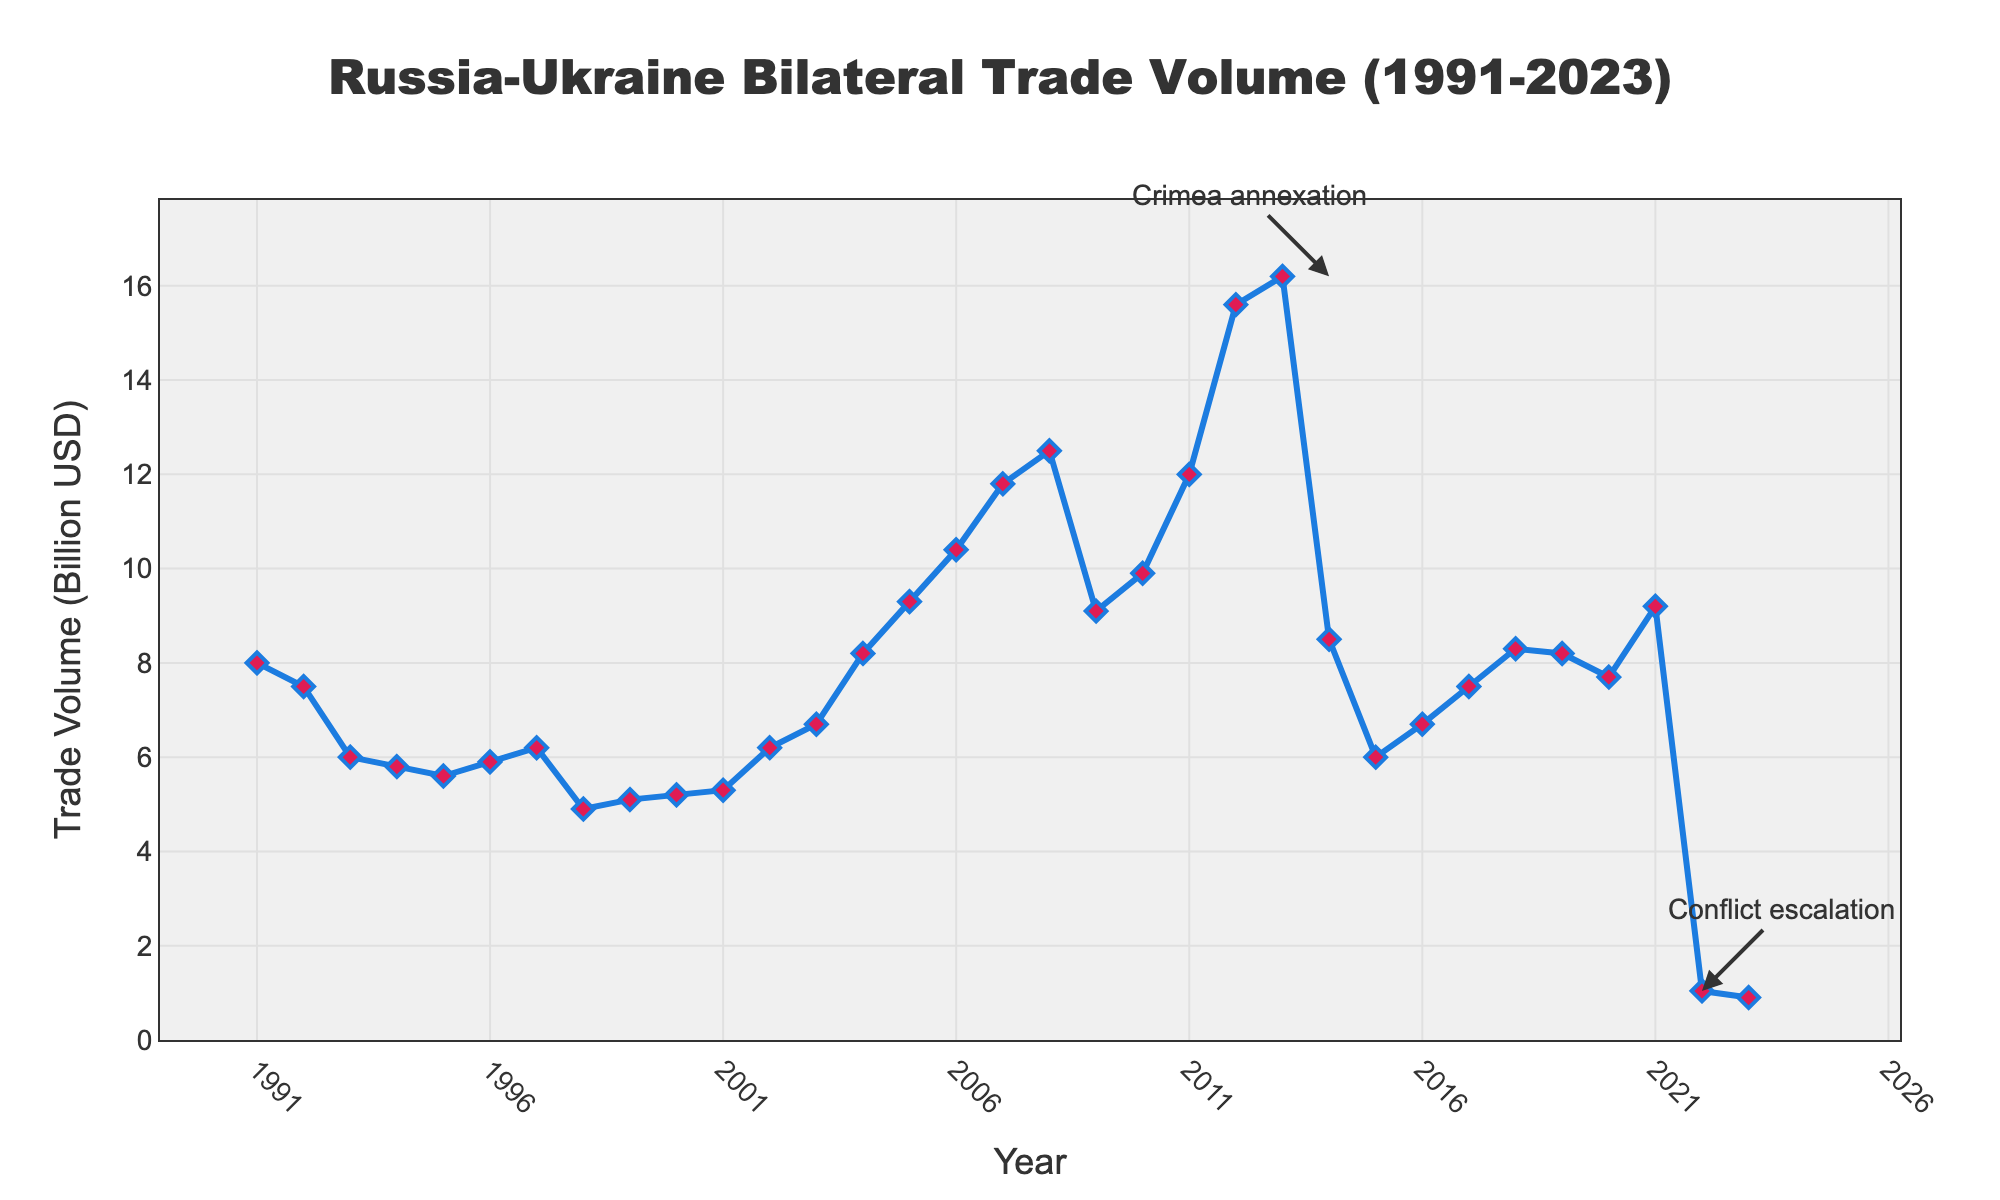What is the title of the figure? The title is typically found at the top center of the figure. It summarizes the main topic of the graph. For this figure, it's indicated by a larger font size and distinctive coloring.
Answer: Russia-Ukraine Bilateral Trade Volume (1991-2023) How many times did the trade volume exceed 10 billion USD? We need to identify all the points where the trade volume crosses the 10 billion USD mark. The y-axis shows trade volume in billion USD and the points on the graph provide the specific values.
Answer: 4 What was the trade volume in 2014? To find the trade volume in 2014, locate the year on the x-axis and follow the vertical line to see the corresponding value on the y-axis.
Answer: 8.5 billion USD During which period did the trade volume show the most significant decrease? To determine the most significant decrease, we need to look for the largest downward slope on the graph. The steepest downward lines between two years indicate the periods with the biggest decreases.
Answer: 2013-2014 Which year had the highest trade volume? To answer this, identify the peak point on the plot and note the corresponding year on the x-axis.
Answer: 2013 What was the impact on trade volume following the Crimea annexation? Look at the trade volume value at 2013 (before the annexation) and compare it with the value at 2014 (after the annexation).
Answer: Trade volume decreased from 16.2 billion USD to 8.5 billion USD How does the trade volume in 2021 compare to that in 2022? Locate both years on the x-axis and compare their corresponding trade volumes from the y-axis values.
Answer: 2021 is much higher at 9.2 billion USD, while 2022 is 1.04 billion USD What trend can be observed in the trade volume from 1991 to 1996? Track the points from 1991 to 1996 to identify if the trade volume increases, decreases, or remains stable.
Answer: Decreasing then stabilizing What can be inferred about the trade relationship from 1998 to 2001? Examine the plot for these years to see if the trade volume shows an increasing, decreasing, or stable trend. This gives insights into the trade dynamics during this period.
Answer: It fluctuates with a small increase overall 